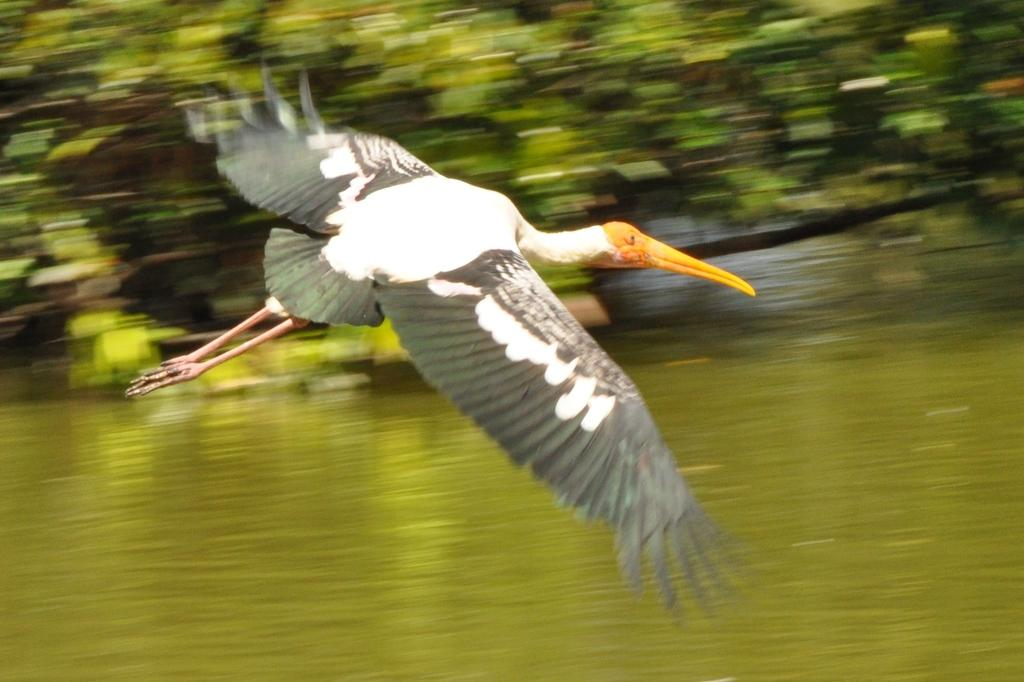What is the primary element visible in the image? There is water in the image. What is the bird doing in the image? The bird is flying in the image. What can be seen in the distance in the image? There are trees in the background of the image. What type of selection process is being used by the water in the image? There is no selection process being used by the water in the image; it is simply a body of water. 